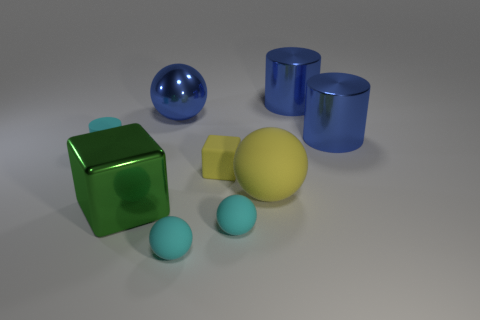Subtract all cyan cubes. How many blue cylinders are left? 2 Subtract all big yellow balls. How many balls are left? 3 Subtract 1 cylinders. How many cylinders are left? 2 Subtract all yellow balls. How many balls are left? 3 Subtract all cylinders. How many objects are left? 6 Add 1 yellow things. How many yellow things exist? 3 Subtract 0 green balls. How many objects are left? 9 Subtract all green balls. Subtract all yellow cylinders. How many balls are left? 4 Subtract all green metallic things. Subtract all tiny yellow matte objects. How many objects are left? 7 Add 6 small cylinders. How many small cylinders are left? 7 